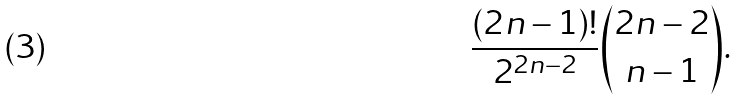<formula> <loc_0><loc_0><loc_500><loc_500>\frac { ( 2 n - 1 ) ! } { 2 ^ { 2 n - 2 } } \binom { 2 n - 2 } { n - 1 } .</formula> 